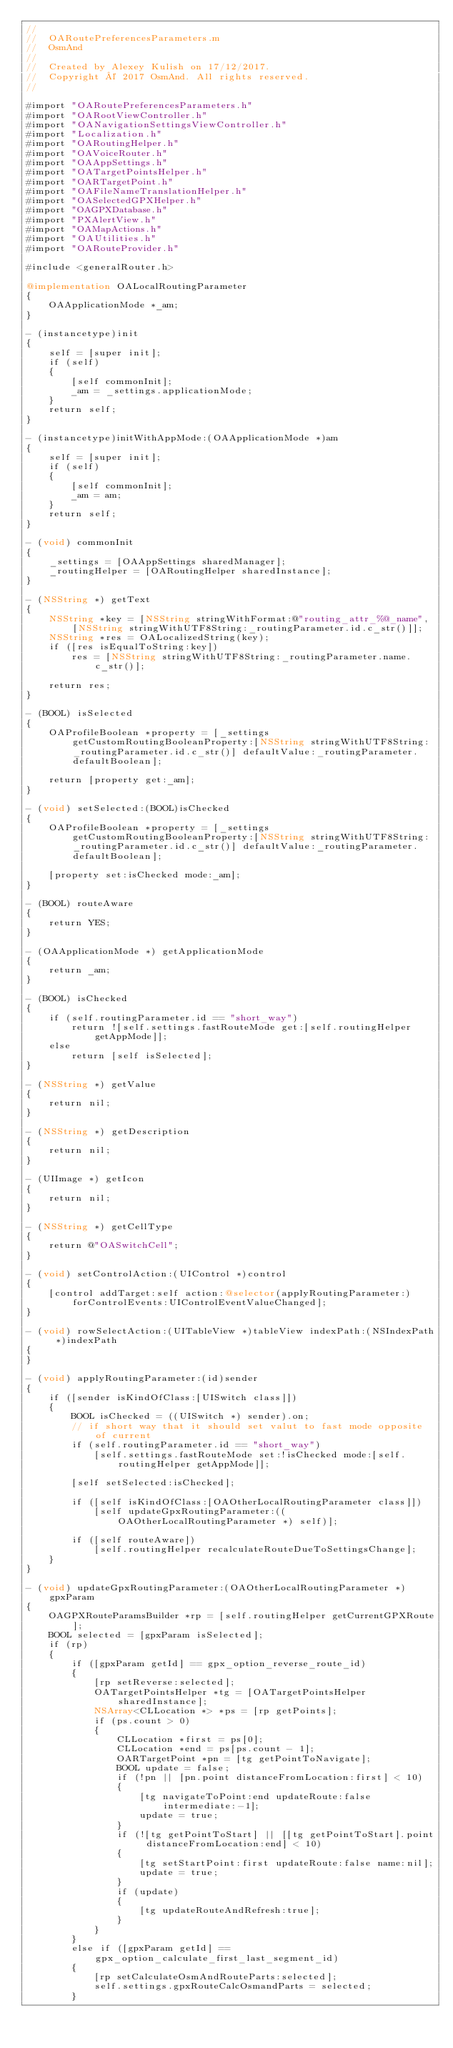Convert code to text. <code><loc_0><loc_0><loc_500><loc_500><_ObjectiveC_>//
//  OARoutePreferencesParameters.m
//  OsmAnd
//
//  Created by Alexey Kulish on 17/12/2017.
//  Copyright © 2017 OsmAnd. All rights reserved.
//

#import "OARoutePreferencesParameters.h"
#import "OARootViewController.h"
#import "OANavigationSettingsViewController.h"
#import "Localization.h"
#import "OARoutingHelper.h"
#import "OAVoiceRouter.h"
#import "OAAppSettings.h"
#import "OATargetPointsHelper.h"
#import "OARTargetPoint.h"
#import "OAFileNameTranslationHelper.h"
#import "OASelectedGPXHelper.h"
#import "OAGPXDatabase.h"
#import "PXAlertView.h"
#import "OAMapActions.h"
#import "OAUtilities.h"
#import "OARouteProvider.h"

#include <generalRouter.h>

@implementation OALocalRoutingParameter
{
    OAApplicationMode *_am;
}

- (instancetype)init
{
    self = [super init];
    if (self)
    {
        [self commonInit];
        _am = _settings.applicationMode;
    }
    return self;
}

- (instancetype)initWithAppMode:(OAApplicationMode *)am
{
    self = [super init];
    if (self)
    {
        [self commonInit];
        _am = am;
    }
    return self;
}

- (void) commonInit
{
    _settings = [OAAppSettings sharedManager];
    _routingHelper = [OARoutingHelper sharedInstance];
}

- (NSString *) getText
{
    NSString *key = [NSString stringWithFormat:@"routing_attr_%@_name", [NSString stringWithUTF8String:_routingParameter.id.c_str()]];
    NSString *res = OALocalizedString(key);
    if ([res isEqualToString:key])
        res = [NSString stringWithUTF8String:_routingParameter.name.c_str()];
    
    return res;
}

- (BOOL) isSelected
{
    OAProfileBoolean *property = [_settings getCustomRoutingBooleanProperty:[NSString stringWithUTF8String:_routingParameter.id.c_str()] defaultValue:_routingParameter.defaultBoolean];
    
    return [property get:_am];
}

- (void) setSelected:(BOOL)isChecked
{
    OAProfileBoolean *property = [_settings getCustomRoutingBooleanProperty:[NSString stringWithUTF8String:_routingParameter.id.c_str()] defaultValue:_routingParameter.defaultBoolean];
    
    [property set:isChecked mode:_am];
}

- (BOOL) routeAware
{
    return YES;
}

- (OAApplicationMode *) getApplicationMode
{
    return _am;
}

- (BOOL) isChecked
{
    if (self.routingParameter.id == "short_way")
        return ![self.settings.fastRouteMode get:[self.routingHelper getAppMode]];
    else
        return [self isSelected];
}

- (NSString *) getValue
{
    return nil;
}

- (NSString *) getDescription
{
    return nil;
}

- (UIImage *) getIcon
{
    return nil;
}

- (NSString *) getCellType
{
    return @"OASwitchCell";
}

- (void) setControlAction:(UIControl *)control
{
    [control addTarget:self action:@selector(applyRoutingParameter:) forControlEvents:UIControlEventValueChanged];
}

- (void) rowSelectAction:(UITableView *)tableView indexPath:(NSIndexPath *)indexPath
{
}

- (void) applyRoutingParameter:(id)sender
{
    if ([sender isKindOfClass:[UISwitch class]])
    {
        BOOL isChecked = ((UISwitch *) sender).on;
        // if short way that it should set valut to fast mode opposite of current
        if (self.routingParameter.id == "short_way")
            [self.settings.fastRouteMode set:!isChecked mode:[self.routingHelper getAppMode]];
        
        [self setSelected:isChecked];
        
        if ([self isKindOfClass:[OAOtherLocalRoutingParameter class]])
            [self updateGpxRoutingParameter:((OAOtherLocalRoutingParameter *) self)];
        
        if ([self routeAware])
            [self.routingHelper recalculateRouteDueToSettingsChange];
    }
}

- (void) updateGpxRoutingParameter:(OAOtherLocalRoutingParameter *)gpxParam
{
    OAGPXRouteParamsBuilder *rp = [self.routingHelper getCurrentGPXRoute];
    BOOL selected = [gpxParam isSelected];
    if (rp)
    {
        if ([gpxParam getId] == gpx_option_reverse_route_id)
        {
            [rp setReverse:selected];
            OATargetPointsHelper *tg = [OATargetPointsHelper sharedInstance];
            NSArray<CLLocation *> *ps = [rp getPoints];
            if (ps.count > 0)
            {
                CLLocation *first = ps[0];
                CLLocation *end = ps[ps.count - 1];
                OARTargetPoint *pn = [tg getPointToNavigate];
                BOOL update = false;
                if (!pn || [pn.point distanceFromLocation:first] < 10)
                {
                    [tg navigateToPoint:end updateRoute:false intermediate:-1];
                    update = true;
                }
                if (![tg getPointToStart] || [[tg getPointToStart].point distanceFromLocation:end] < 10)
                {
                    [tg setStartPoint:first updateRoute:false name:nil];
                    update = true;
                }
                if (update)
                {
                    [tg updateRouteAndRefresh:true];
                }
            }
        }
        else if ([gpxParam getId] == gpx_option_calculate_first_last_segment_id)
        {
            [rp setCalculateOsmAndRouteParts:selected];
            self.settings.gpxRouteCalcOsmandParts = selected;
        }</code> 